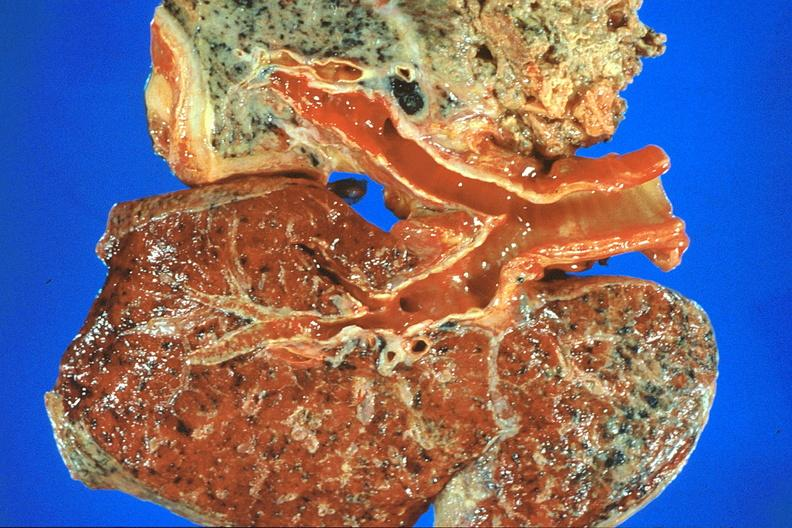s mesentery present?
Answer the question using a single word or phrase. No 